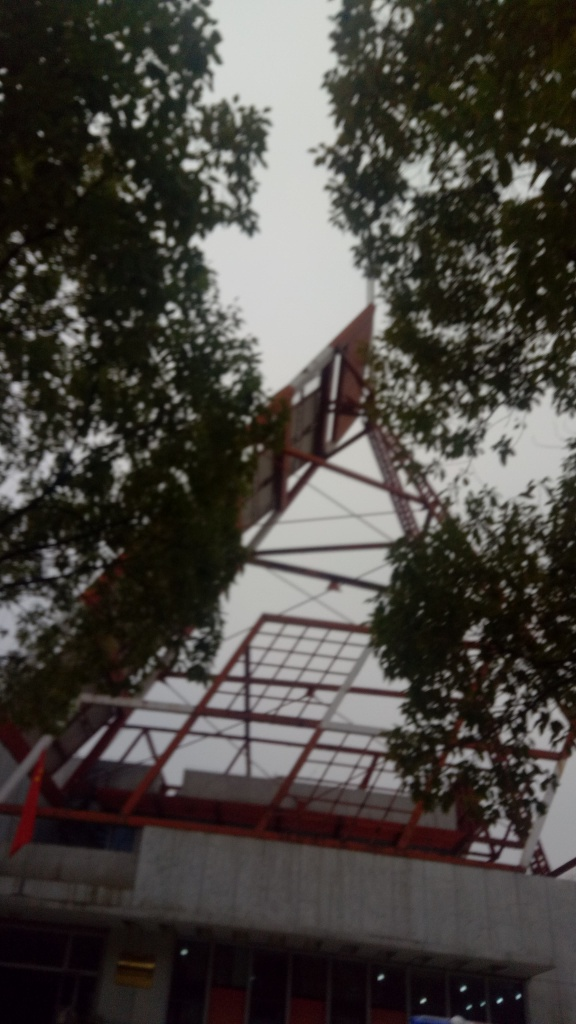The photo seems a bit blurry. What could be the reason for this? The blurriness in the photo could be due to a number of factors: it may have been taken with a low shutter speed while the camera was moving, the autofocus may not have been properly set, or the lens might have been smudged or fogged up. It's also possible that the photo was taken in haste or through a moving vehicle. 